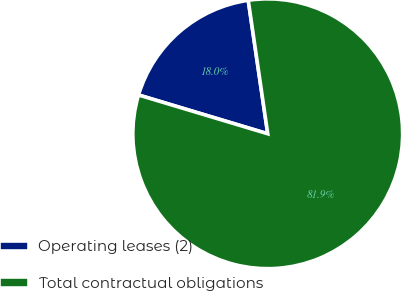Convert chart. <chart><loc_0><loc_0><loc_500><loc_500><pie_chart><fcel>Operating leases (2)<fcel>Total contractual obligations<nl><fcel>18.05%<fcel>81.95%<nl></chart> 